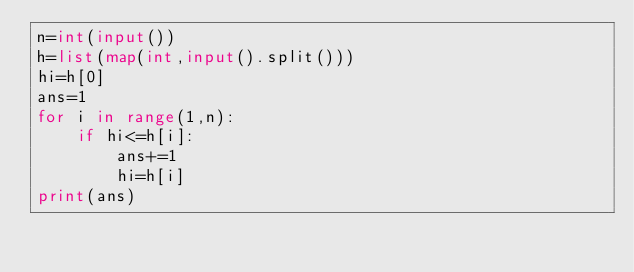Convert code to text. <code><loc_0><loc_0><loc_500><loc_500><_Python_>n=int(input())
h=list(map(int,input().split()))
hi=h[0]
ans=1
for i in range(1,n):
    if hi<=h[i]:
        ans+=1
        hi=h[i]
print(ans)</code> 